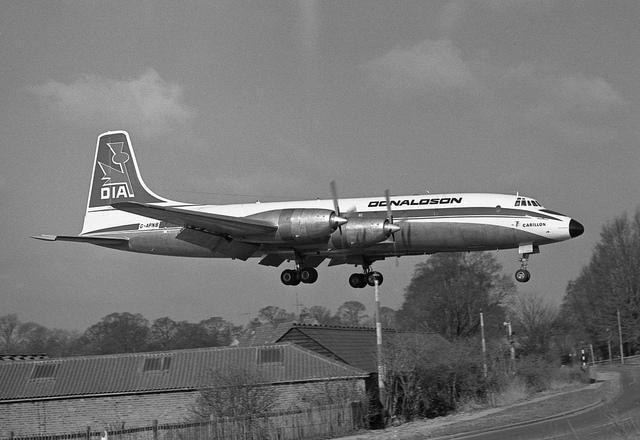How many letter D are on the plane?
Give a very brief answer. 3. How many already fried donuts are there in the image?
Give a very brief answer. 0. 